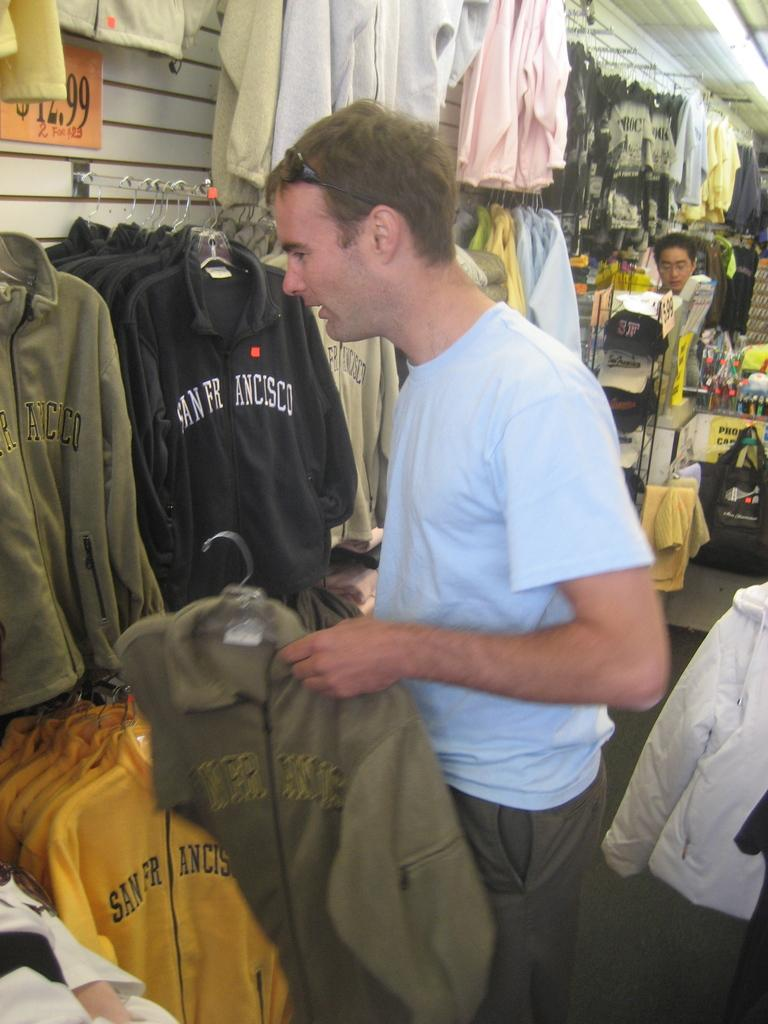<image>
Share a concise interpretation of the image provided. A man looks at several jackets with San Francisco on them in a shop 